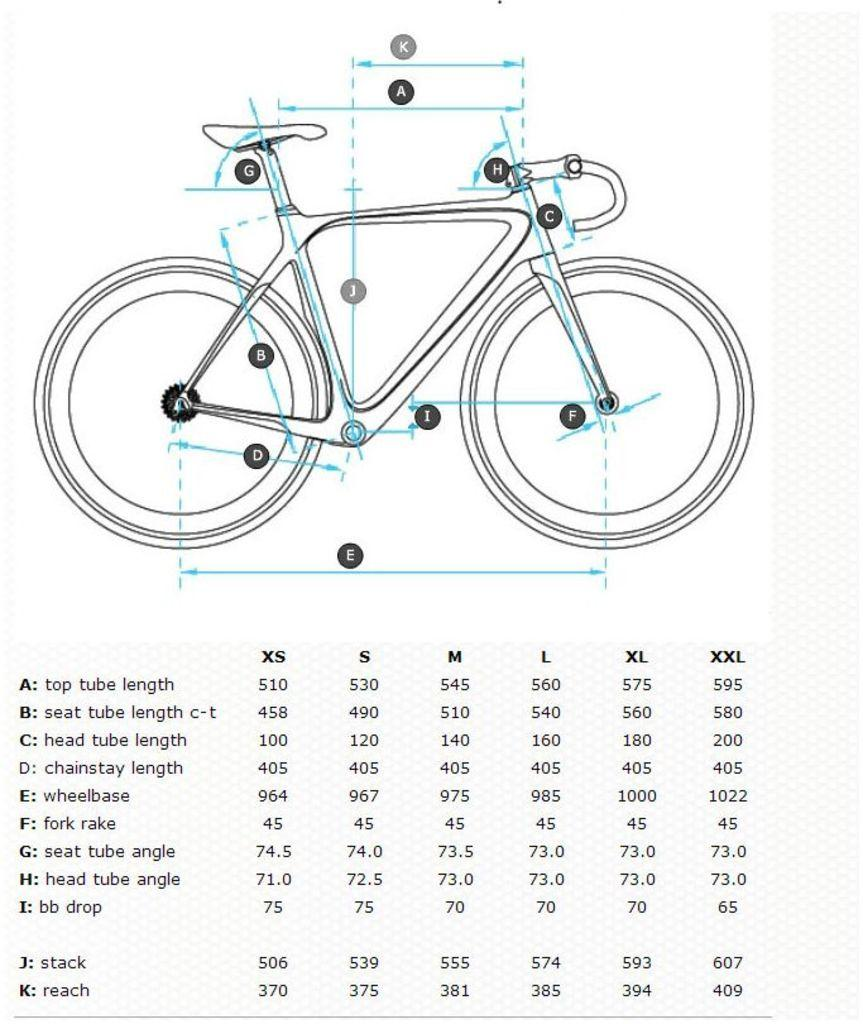<image>
Create a compact narrative representing the image presented. A bicycle assembly guide shows the lengths of various bicycle parts by sizes from XS to XXL 